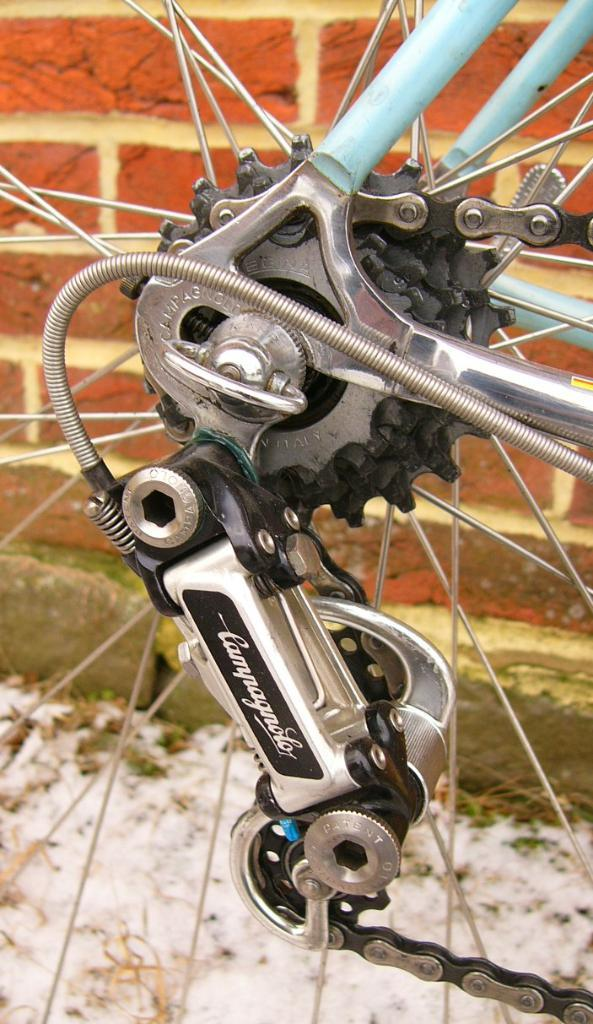What type of objects can be seen in the image? In the image, there are rims, a chain, rods, and a gear set. Can you describe the arrangement of these objects? The objects are arranged in a way that suggests they are part of a mechanical system. What is visible in the background of the image? There is a wall in the background of the image. How does the knot in the image help to secure the gear set? There is no knot present in the image; it only features rims, a chain, rods, and a gear set. 